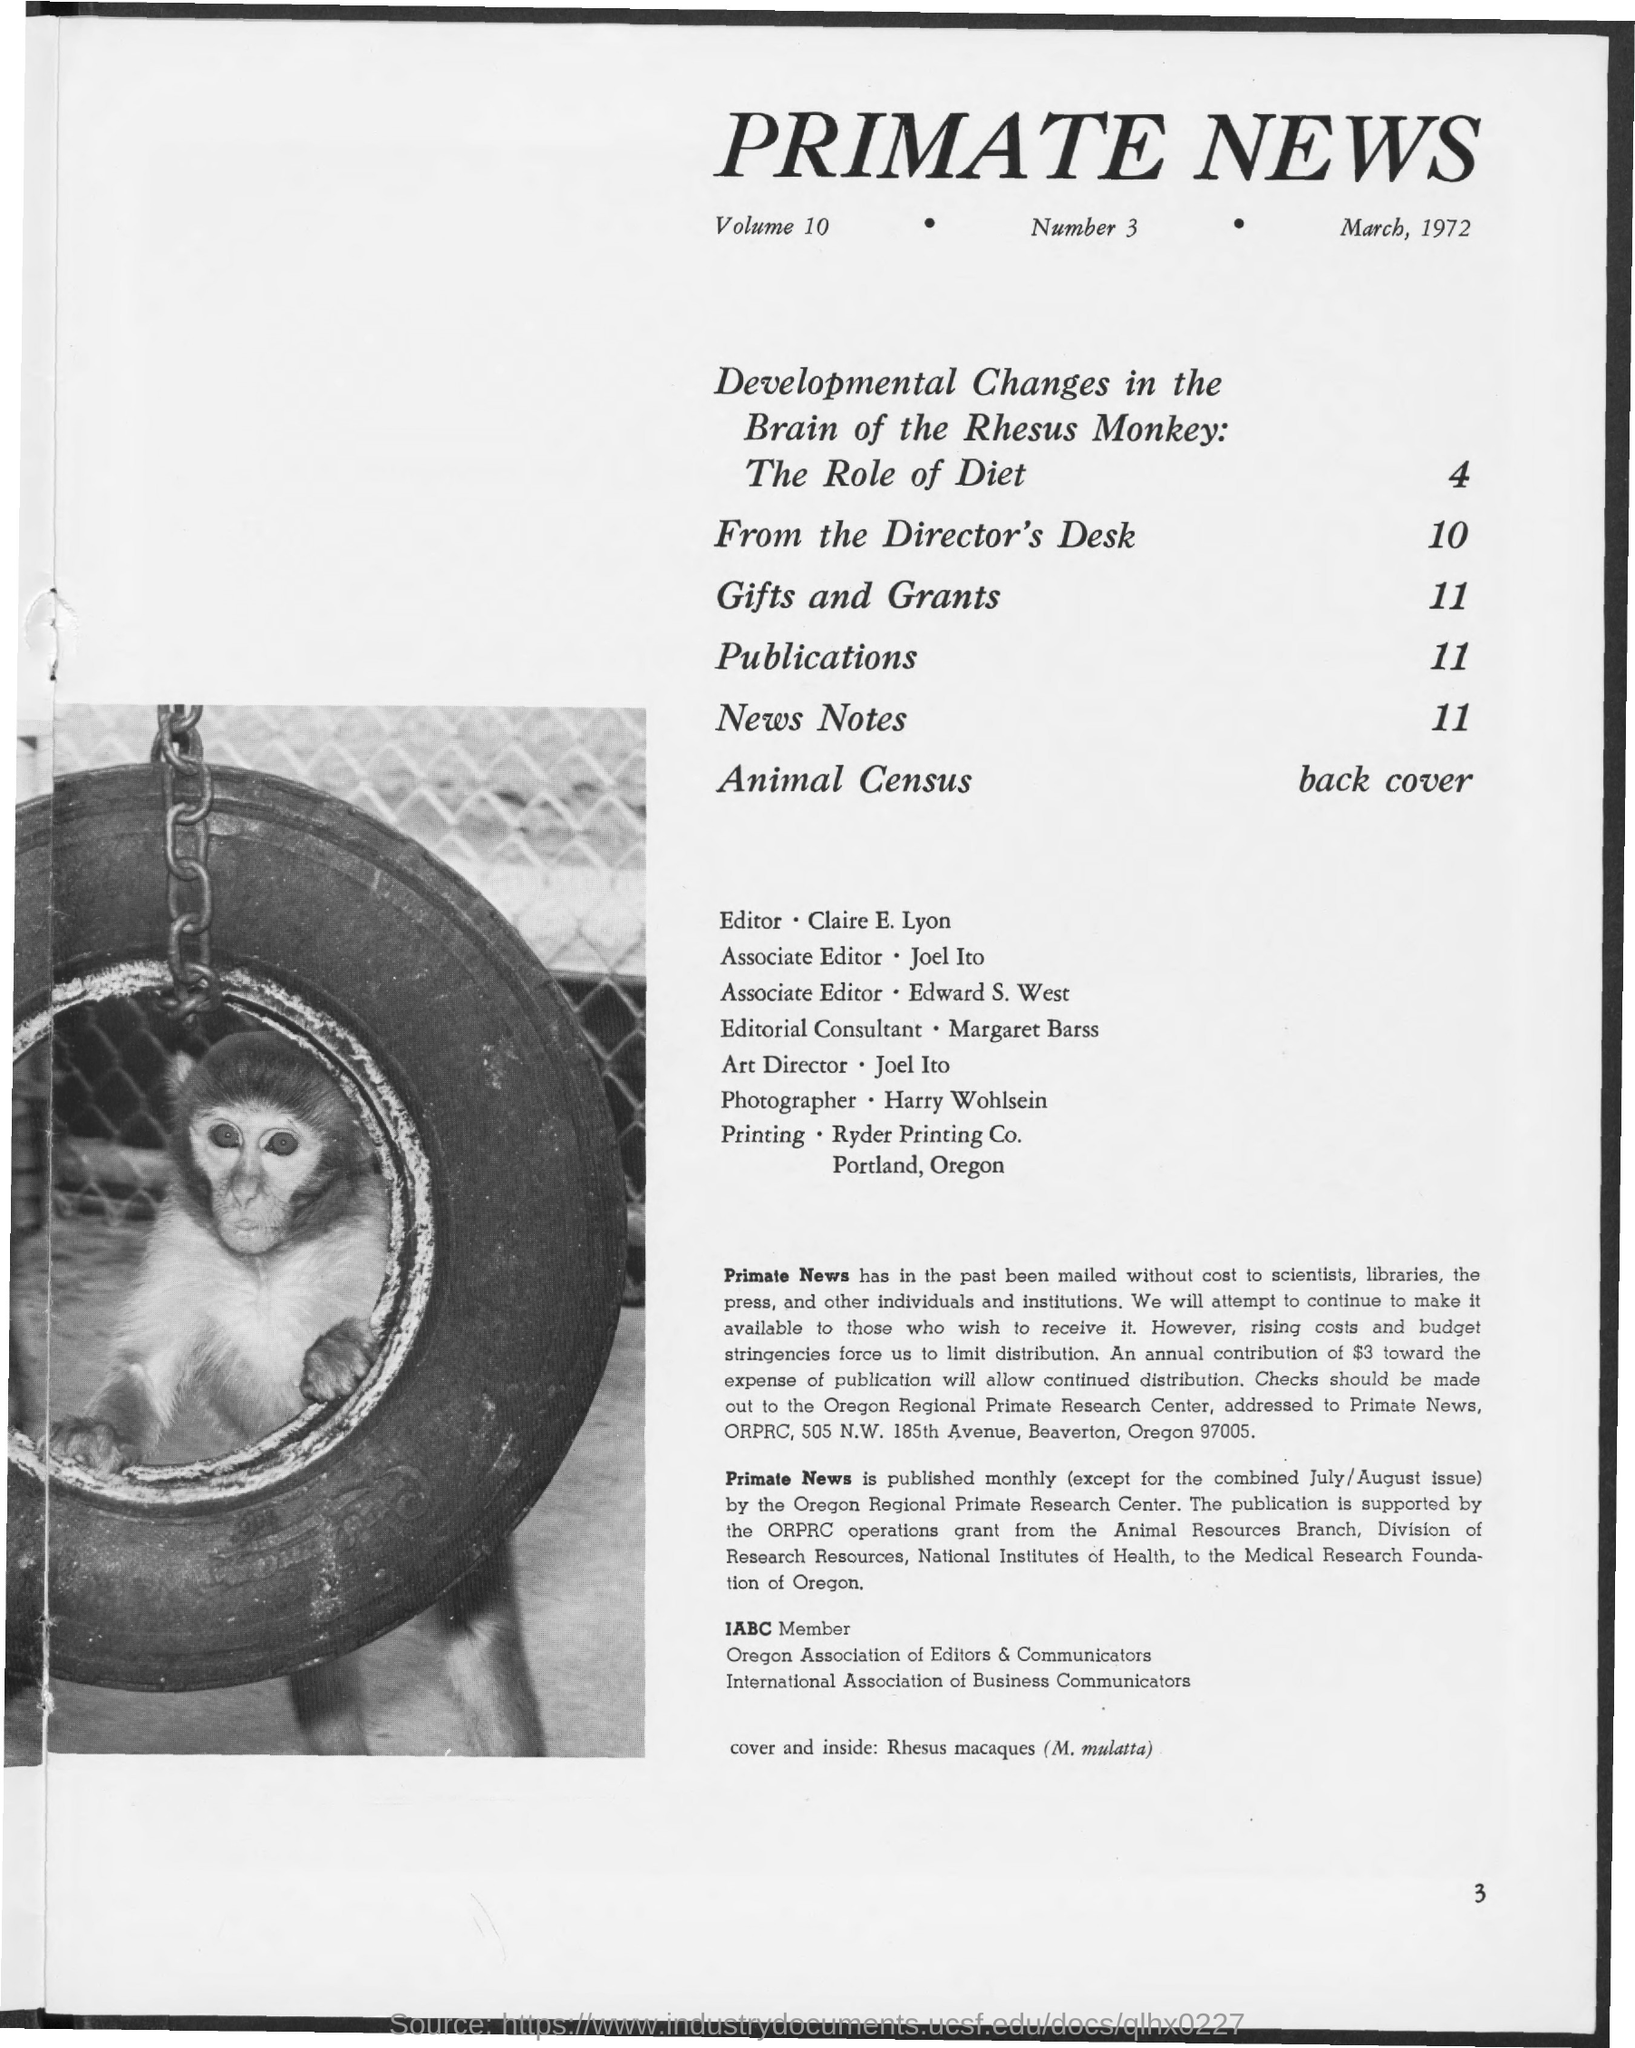What is the Title of the document?
Ensure brevity in your answer.  Primate News. Who is the Editor?
Provide a short and direct response. Claire e. lyon. Who is the Art Director?
Keep it short and to the point. Joel Ito. Who is the Photographer?
Your answer should be very brief. Harry wohlsein. Which page Number is "New Notes" in?
Provide a short and direct response. 11. 